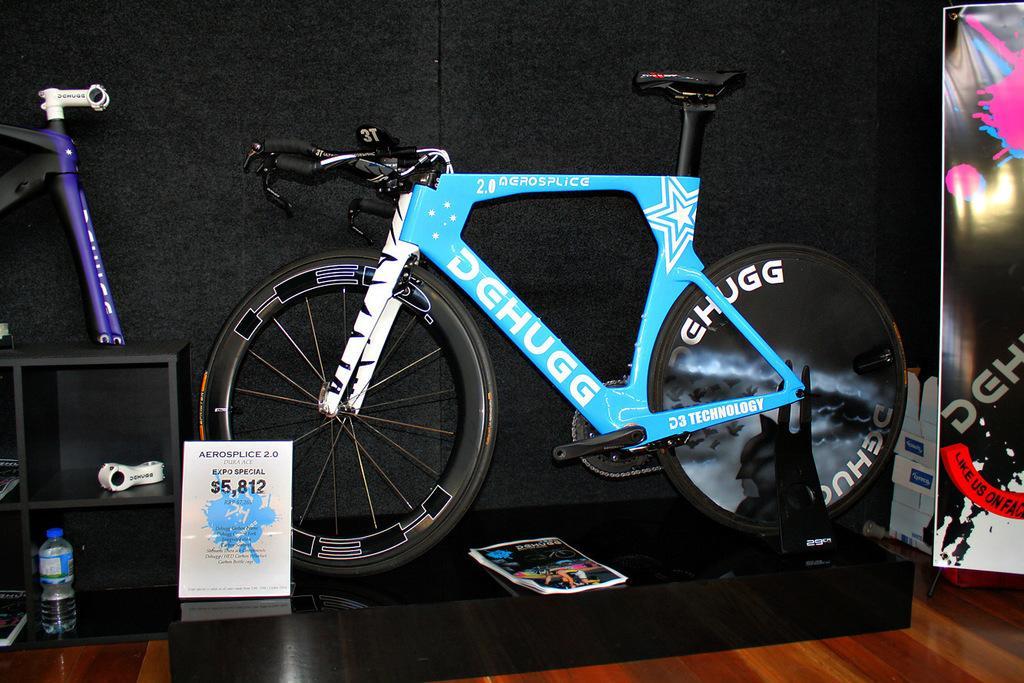How would you summarize this image in a sentence or two? In this image I can see the bicycle on the black color surface. In-front of it I can see the board and the paper. To the left I can see the front part of the bicycle, bottle and few books in the shelves. To the right I can see the banner and few more objects. And there is a black background. 